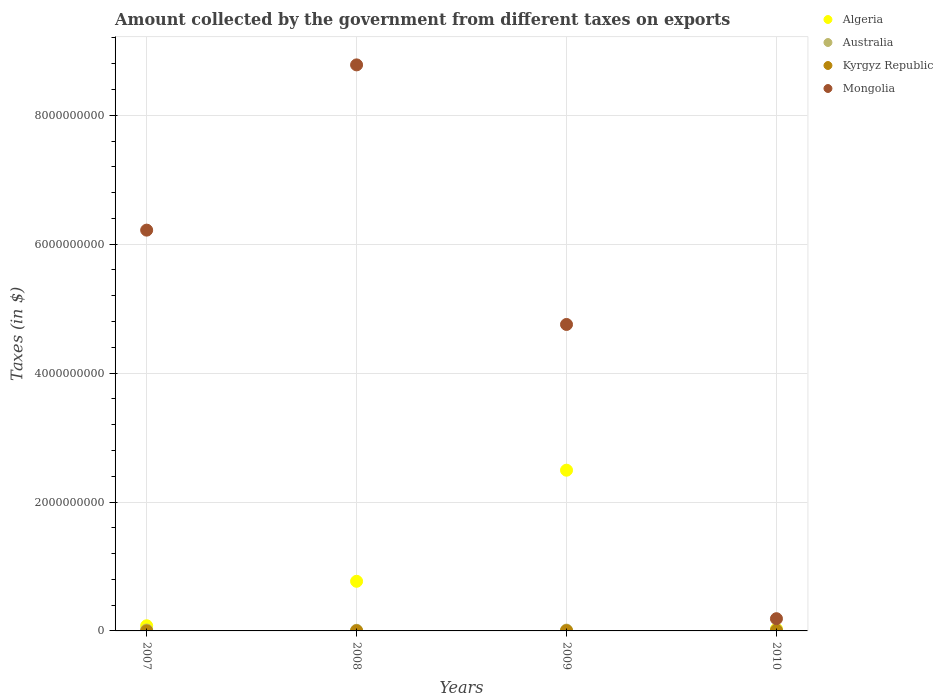What is the amount collected by the government from taxes on exports in Kyrgyz Republic in 2008?
Offer a terse response. 1.81e+06. Across all years, what is the maximum amount collected by the government from taxes on exports in Kyrgyz Republic?
Make the answer very short. 5.91e+06. Across all years, what is the minimum amount collected by the government from taxes on exports in Australia?
Your response must be concise. 1.00e+07. In which year was the amount collected by the government from taxes on exports in Mongolia minimum?
Offer a very short reply. 2010. What is the total amount collected by the government from taxes on exports in Mongolia in the graph?
Keep it short and to the point. 1.99e+1. What is the difference between the amount collected by the government from taxes on exports in Kyrgyz Republic in 2008 and that in 2009?
Make the answer very short. -1.76e+06. What is the difference between the amount collected by the government from taxes on exports in Mongolia in 2008 and the amount collected by the government from taxes on exports in Australia in 2007?
Make the answer very short. 8.77e+09. What is the average amount collected by the government from taxes on exports in Algeria per year?
Make the answer very short. 8.43e+08. In the year 2008, what is the difference between the amount collected by the government from taxes on exports in Kyrgyz Republic and amount collected by the government from taxes on exports in Algeria?
Your answer should be very brief. -7.68e+08. In how many years, is the amount collected by the government from taxes on exports in Australia greater than 800000000 $?
Provide a succinct answer. 0. What is the ratio of the amount collected by the government from taxes on exports in Australia in 2007 to that in 2009?
Your response must be concise. 1.08. What is the difference between the highest and the second highest amount collected by the government from taxes on exports in Algeria?
Give a very brief answer. 1.72e+09. What is the difference between the highest and the lowest amount collected by the government from taxes on exports in Mongolia?
Provide a succinct answer. 8.59e+09. In how many years, is the amount collected by the government from taxes on exports in Australia greater than the average amount collected by the government from taxes on exports in Australia taken over all years?
Make the answer very short. 3. Is it the case that in every year, the sum of the amount collected by the government from taxes on exports in Mongolia and amount collected by the government from taxes on exports in Australia  is greater than the sum of amount collected by the government from taxes on exports in Algeria and amount collected by the government from taxes on exports in Kyrgyz Republic?
Make the answer very short. No. Is the amount collected by the government from taxes on exports in Kyrgyz Republic strictly less than the amount collected by the government from taxes on exports in Mongolia over the years?
Give a very brief answer. Yes. How many dotlines are there?
Keep it short and to the point. 4. How many years are there in the graph?
Give a very brief answer. 4. What is the difference between two consecutive major ticks on the Y-axis?
Your answer should be very brief. 2.00e+09. Where does the legend appear in the graph?
Ensure brevity in your answer.  Top right. How are the legend labels stacked?
Give a very brief answer. Vertical. What is the title of the graph?
Your answer should be compact. Amount collected by the government from different taxes on exports. What is the label or title of the X-axis?
Offer a terse response. Years. What is the label or title of the Y-axis?
Give a very brief answer. Taxes (in $). What is the Taxes (in $) in Algeria in 2007?
Offer a terse response. 8.00e+07. What is the Taxes (in $) in Australia in 2007?
Your response must be concise. 1.40e+07. What is the Taxes (in $) in Kyrgyz Republic in 2007?
Offer a terse response. 1.46e+05. What is the Taxes (in $) of Mongolia in 2007?
Keep it short and to the point. 6.22e+09. What is the Taxes (in $) of Algeria in 2008?
Make the answer very short. 7.70e+08. What is the Taxes (in $) of Kyrgyz Republic in 2008?
Provide a short and direct response. 1.81e+06. What is the Taxes (in $) of Mongolia in 2008?
Your answer should be very brief. 8.78e+09. What is the Taxes (in $) of Algeria in 2009?
Your response must be concise. 2.49e+09. What is the Taxes (in $) in Australia in 2009?
Provide a succinct answer. 1.30e+07. What is the Taxes (in $) in Kyrgyz Republic in 2009?
Ensure brevity in your answer.  3.56e+06. What is the Taxes (in $) in Mongolia in 2009?
Your answer should be very brief. 4.75e+09. What is the Taxes (in $) in Algeria in 2010?
Your answer should be very brief. 3.00e+07. What is the Taxes (in $) of Australia in 2010?
Ensure brevity in your answer.  1.40e+07. What is the Taxes (in $) in Kyrgyz Republic in 2010?
Ensure brevity in your answer.  5.91e+06. What is the Taxes (in $) of Mongolia in 2010?
Give a very brief answer. 1.90e+08. Across all years, what is the maximum Taxes (in $) of Algeria?
Ensure brevity in your answer.  2.49e+09. Across all years, what is the maximum Taxes (in $) in Australia?
Ensure brevity in your answer.  1.40e+07. Across all years, what is the maximum Taxes (in $) in Kyrgyz Republic?
Make the answer very short. 5.91e+06. Across all years, what is the maximum Taxes (in $) in Mongolia?
Offer a terse response. 8.78e+09. Across all years, what is the minimum Taxes (in $) in Algeria?
Provide a succinct answer. 3.00e+07. Across all years, what is the minimum Taxes (in $) in Kyrgyz Republic?
Your answer should be compact. 1.46e+05. Across all years, what is the minimum Taxes (in $) of Mongolia?
Your answer should be very brief. 1.90e+08. What is the total Taxes (in $) of Algeria in the graph?
Your response must be concise. 3.37e+09. What is the total Taxes (in $) of Australia in the graph?
Ensure brevity in your answer.  5.10e+07. What is the total Taxes (in $) of Kyrgyz Republic in the graph?
Your response must be concise. 1.14e+07. What is the total Taxes (in $) in Mongolia in the graph?
Offer a very short reply. 1.99e+1. What is the difference between the Taxes (in $) of Algeria in 2007 and that in 2008?
Your response must be concise. -6.90e+08. What is the difference between the Taxes (in $) in Australia in 2007 and that in 2008?
Provide a short and direct response. 4.00e+06. What is the difference between the Taxes (in $) of Kyrgyz Republic in 2007 and that in 2008?
Make the answer very short. -1.66e+06. What is the difference between the Taxes (in $) of Mongolia in 2007 and that in 2008?
Provide a short and direct response. -2.56e+09. What is the difference between the Taxes (in $) of Algeria in 2007 and that in 2009?
Provide a succinct answer. -2.41e+09. What is the difference between the Taxes (in $) of Australia in 2007 and that in 2009?
Your response must be concise. 1.00e+06. What is the difference between the Taxes (in $) in Kyrgyz Republic in 2007 and that in 2009?
Provide a succinct answer. -3.42e+06. What is the difference between the Taxes (in $) in Mongolia in 2007 and that in 2009?
Your answer should be very brief. 1.46e+09. What is the difference between the Taxes (in $) in Algeria in 2007 and that in 2010?
Provide a short and direct response. 5.00e+07. What is the difference between the Taxes (in $) of Kyrgyz Republic in 2007 and that in 2010?
Make the answer very short. -5.77e+06. What is the difference between the Taxes (in $) in Mongolia in 2007 and that in 2010?
Provide a short and direct response. 6.03e+09. What is the difference between the Taxes (in $) in Algeria in 2008 and that in 2009?
Keep it short and to the point. -1.72e+09. What is the difference between the Taxes (in $) of Kyrgyz Republic in 2008 and that in 2009?
Make the answer very short. -1.76e+06. What is the difference between the Taxes (in $) in Mongolia in 2008 and that in 2009?
Keep it short and to the point. 4.03e+09. What is the difference between the Taxes (in $) of Algeria in 2008 and that in 2010?
Offer a very short reply. 7.40e+08. What is the difference between the Taxes (in $) in Australia in 2008 and that in 2010?
Keep it short and to the point. -4.00e+06. What is the difference between the Taxes (in $) of Kyrgyz Republic in 2008 and that in 2010?
Offer a very short reply. -4.11e+06. What is the difference between the Taxes (in $) in Mongolia in 2008 and that in 2010?
Your answer should be compact. 8.59e+09. What is the difference between the Taxes (in $) of Algeria in 2009 and that in 2010?
Keep it short and to the point. 2.46e+09. What is the difference between the Taxes (in $) of Australia in 2009 and that in 2010?
Keep it short and to the point. -1.00e+06. What is the difference between the Taxes (in $) in Kyrgyz Republic in 2009 and that in 2010?
Ensure brevity in your answer.  -2.35e+06. What is the difference between the Taxes (in $) in Mongolia in 2009 and that in 2010?
Provide a short and direct response. 4.57e+09. What is the difference between the Taxes (in $) of Algeria in 2007 and the Taxes (in $) of Australia in 2008?
Provide a short and direct response. 7.00e+07. What is the difference between the Taxes (in $) of Algeria in 2007 and the Taxes (in $) of Kyrgyz Republic in 2008?
Provide a short and direct response. 7.82e+07. What is the difference between the Taxes (in $) of Algeria in 2007 and the Taxes (in $) of Mongolia in 2008?
Provide a succinct answer. -8.70e+09. What is the difference between the Taxes (in $) of Australia in 2007 and the Taxes (in $) of Kyrgyz Republic in 2008?
Make the answer very short. 1.22e+07. What is the difference between the Taxes (in $) of Australia in 2007 and the Taxes (in $) of Mongolia in 2008?
Keep it short and to the point. -8.77e+09. What is the difference between the Taxes (in $) of Kyrgyz Republic in 2007 and the Taxes (in $) of Mongolia in 2008?
Give a very brief answer. -8.78e+09. What is the difference between the Taxes (in $) in Algeria in 2007 and the Taxes (in $) in Australia in 2009?
Provide a short and direct response. 6.70e+07. What is the difference between the Taxes (in $) in Algeria in 2007 and the Taxes (in $) in Kyrgyz Republic in 2009?
Give a very brief answer. 7.64e+07. What is the difference between the Taxes (in $) in Algeria in 2007 and the Taxes (in $) in Mongolia in 2009?
Your answer should be compact. -4.67e+09. What is the difference between the Taxes (in $) in Australia in 2007 and the Taxes (in $) in Kyrgyz Republic in 2009?
Ensure brevity in your answer.  1.04e+07. What is the difference between the Taxes (in $) in Australia in 2007 and the Taxes (in $) in Mongolia in 2009?
Keep it short and to the point. -4.74e+09. What is the difference between the Taxes (in $) in Kyrgyz Republic in 2007 and the Taxes (in $) in Mongolia in 2009?
Ensure brevity in your answer.  -4.75e+09. What is the difference between the Taxes (in $) in Algeria in 2007 and the Taxes (in $) in Australia in 2010?
Make the answer very short. 6.60e+07. What is the difference between the Taxes (in $) in Algeria in 2007 and the Taxes (in $) in Kyrgyz Republic in 2010?
Provide a succinct answer. 7.41e+07. What is the difference between the Taxes (in $) of Algeria in 2007 and the Taxes (in $) of Mongolia in 2010?
Make the answer very short. -1.10e+08. What is the difference between the Taxes (in $) of Australia in 2007 and the Taxes (in $) of Kyrgyz Republic in 2010?
Your response must be concise. 8.09e+06. What is the difference between the Taxes (in $) in Australia in 2007 and the Taxes (in $) in Mongolia in 2010?
Your answer should be very brief. -1.76e+08. What is the difference between the Taxes (in $) of Kyrgyz Republic in 2007 and the Taxes (in $) of Mongolia in 2010?
Keep it short and to the point. -1.90e+08. What is the difference between the Taxes (in $) in Algeria in 2008 and the Taxes (in $) in Australia in 2009?
Your response must be concise. 7.57e+08. What is the difference between the Taxes (in $) in Algeria in 2008 and the Taxes (in $) in Kyrgyz Republic in 2009?
Offer a terse response. 7.66e+08. What is the difference between the Taxes (in $) in Algeria in 2008 and the Taxes (in $) in Mongolia in 2009?
Keep it short and to the point. -3.98e+09. What is the difference between the Taxes (in $) in Australia in 2008 and the Taxes (in $) in Kyrgyz Republic in 2009?
Give a very brief answer. 6.44e+06. What is the difference between the Taxes (in $) in Australia in 2008 and the Taxes (in $) in Mongolia in 2009?
Make the answer very short. -4.74e+09. What is the difference between the Taxes (in $) of Kyrgyz Republic in 2008 and the Taxes (in $) of Mongolia in 2009?
Make the answer very short. -4.75e+09. What is the difference between the Taxes (in $) in Algeria in 2008 and the Taxes (in $) in Australia in 2010?
Your answer should be very brief. 7.56e+08. What is the difference between the Taxes (in $) in Algeria in 2008 and the Taxes (in $) in Kyrgyz Republic in 2010?
Offer a terse response. 7.64e+08. What is the difference between the Taxes (in $) of Algeria in 2008 and the Taxes (in $) of Mongolia in 2010?
Keep it short and to the point. 5.80e+08. What is the difference between the Taxes (in $) in Australia in 2008 and the Taxes (in $) in Kyrgyz Republic in 2010?
Keep it short and to the point. 4.09e+06. What is the difference between the Taxes (in $) in Australia in 2008 and the Taxes (in $) in Mongolia in 2010?
Your answer should be compact. -1.80e+08. What is the difference between the Taxes (in $) of Kyrgyz Republic in 2008 and the Taxes (in $) of Mongolia in 2010?
Ensure brevity in your answer.  -1.88e+08. What is the difference between the Taxes (in $) of Algeria in 2009 and the Taxes (in $) of Australia in 2010?
Make the answer very short. 2.48e+09. What is the difference between the Taxes (in $) in Algeria in 2009 and the Taxes (in $) in Kyrgyz Republic in 2010?
Ensure brevity in your answer.  2.49e+09. What is the difference between the Taxes (in $) of Algeria in 2009 and the Taxes (in $) of Mongolia in 2010?
Give a very brief answer. 2.30e+09. What is the difference between the Taxes (in $) of Australia in 2009 and the Taxes (in $) of Kyrgyz Republic in 2010?
Your response must be concise. 7.09e+06. What is the difference between the Taxes (in $) of Australia in 2009 and the Taxes (in $) of Mongolia in 2010?
Provide a short and direct response. -1.77e+08. What is the difference between the Taxes (in $) in Kyrgyz Republic in 2009 and the Taxes (in $) in Mongolia in 2010?
Offer a very short reply. -1.86e+08. What is the average Taxes (in $) of Algeria per year?
Give a very brief answer. 8.43e+08. What is the average Taxes (in $) of Australia per year?
Give a very brief answer. 1.28e+07. What is the average Taxes (in $) of Kyrgyz Republic per year?
Provide a short and direct response. 2.86e+06. What is the average Taxes (in $) of Mongolia per year?
Keep it short and to the point. 4.99e+09. In the year 2007, what is the difference between the Taxes (in $) in Algeria and Taxes (in $) in Australia?
Provide a short and direct response. 6.60e+07. In the year 2007, what is the difference between the Taxes (in $) in Algeria and Taxes (in $) in Kyrgyz Republic?
Ensure brevity in your answer.  7.99e+07. In the year 2007, what is the difference between the Taxes (in $) in Algeria and Taxes (in $) in Mongolia?
Offer a terse response. -6.14e+09. In the year 2007, what is the difference between the Taxes (in $) of Australia and Taxes (in $) of Kyrgyz Republic?
Give a very brief answer. 1.39e+07. In the year 2007, what is the difference between the Taxes (in $) of Australia and Taxes (in $) of Mongolia?
Give a very brief answer. -6.20e+09. In the year 2007, what is the difference between the Taxes (in $) in Kyrgyz Republic and Taxes (in $) in Mongolia?
Give a very brief answer. -6.22e+09. In the year 2008, what is the difference between the Taxes (in $) of Algeria and Taxes (in $) of Australia?
Keep it short and to the point. 7.60e+08. In the year 2008, what is the difference between the Taxes (in $) in Algeria and Taxes (in $) in Kyrgyz Republic?
Your answer should be very brief. 7.68e+08. In the year 2008, what is the difference between the Taxes (in $) in Algeria and Taxes (in $) in Mongolia?
Make the answer very short. -8.01e+09. In the year 2008, what is the difference between the Taxes (in $) of Australia and Taxes (in $) of Kyrgyz Republic?
Provide a succinct answer. 8.19e+06. In the year 2008, what is the difference between the Taxes (in $) in Australia and Taxes (in $) in Mongolia?
Offer a very short reply. -8.77e+09. In the year 2008, what is the difference between the Taxes (in $) of Kyrgyz Republic and Taxes (in $) of Mongolia?
Offer a very short reply. -8.78e+09. In the year 2009, what is the difference between the Taxes (in $) in Algeria and Taxes (in $) in Australia?
Your answer should be very brief. 2.48e+09. In the year 2009, what is the difference between the Taxes (in $) in Algeria and Taxes (in $) in Kyrgyz Republic?
Provide a short and direct response. 2.49e+09. In the year 2009, what is the difference between the Taxes (in $) of Algeria and Taxes (in $) of Mongolia?
Keep it short and to the point. -2.26e+09. In the year 2009, what is the difference between the Taxes (in $) in Australia and Taxes (in $) in Kyrgyz Republic?
Offer a very short reply. 9.44e+06. In the year 2009, what is the difference between the Taxes (in $) in Australia and Taxes (in $) in Mongolia?
Give a very brief answer. -4.74e+09. In the year 2009, what is the difference between the Taxes (in $) of Kyrgyz Republic and Taxes (in $) of Mongolia?
Keep it short and to the point. -4.75e+09. In the year 2010, what is the difference between the Taxes (in $) of Algeria and Taxes (in $) of Australia?
Your answer should be very brief. 1.60e+07. In the year 2010, what is the difference between the Taxes (in $) in Algeria and Taxes (in $) in Kyrgyz Republic?
Ensure brevity in your answer.  2.41e+07. In the year 2010, what is the difference between the Taxes (in $) in Algeria and Taxes (in $) in Mongolia?
Give a very brief answer. -1.60e+08. In the year 2010, what is the difference between the Taxes (in $) of Australia and Taxes (in $) of Kyrgyz Republic?
Ensure brevity in your answer.  8.09e+06. In the year 2010, what is the difference between the Taxes (in $) in Australia and Taxes (in $) in Mongolia?
Ensure brevity in your answer.  -1.76e+08. In the year 2010, what is the difference between the Taxes (in $) in Kyrgyz Republic and Taxes (in $) in Mongolia?
Give a very brief answer. -1.84e+08. What is the ratio of the Taxes (in $) in Algeria in 2007 to that in 2008?
Ensure brevity in your answer.  0.1. What is the ratio of the Taxes (in $) in Kyrgyz Republic in 2007 to that in 2008?
Your answer should be very brief. 0.08. What is the ratio of the Taxes (in $) in Mongolia in 2007 to that in 2008?
Offer a terse response. 0.71. What is the ratio of the Taxes (in $) of Algeria in 2007 to that in 2009?
Provide a short and direct response. 0.03. What is the ratio of the Taxes (in $) of Australia in 2007 to that in 2009?
Ensure brevity in your answer.  1.08. What is the ratio of the Taxes (in $) in Kyrgyz Republic in 2007 to that in 2009?
Offer a terse response. 0.04. What is the ratio of the Taxes (in $) of Mongolia in 2007 to that in 2009?
Keep it short and to the point. 1.31. What is the ratio of the Taxes (in $) of Algeria in 2007 to that in 2010?
Keep it short and to the point. 2.67. What is the ratio of the Taxes (in $) of Australia in 2007 to that in 2010?
Keep it short and to the point. 1. What is the ratio of the Taxes (in $) in Kyrgyz Republic in 2007 to that in 2010?
Keep it short and to the point. 0.02. What is the ratio of the Taxes (in $) of Mongolia in 2007 to that in 2010?
Provide a short and direct response. 32.76. What is the ratio of the Taxes (in $) of Algeria in 2008 to that in 2009?
Keep it short and to the point. 0.31. What is the ratio of the Taxes (in $) of Australia in 2008 to that in 2009?
Make the answer very short. 0.77. What is the ratio of the Taxes (in $) in Kyrgyz Republic in 2008 to that in 2009?
Give a very brief answer. 0.51. What is the ratio of the Taxes (in $) in Mongolia in 2008 to that in 2009?
Your answer should be compact. 1.85. What is the ratio of the Taxes (in $) in Algeria in 2008 to that in 2010?
Offer a very short reply. 25.67. What is the ratio of the Taxes (in $) of Kyrgyz Republic in 2008 to that in 2010?
Provide a short and direct response. 0.31. What is the ratio of the Taxes (in $) of Mongolia in 2008 to that in 2010?
Give a very brief answer. 46.27. What is the ratio of the Taxes (in $) in Algeria in 2009 to that in 2010?
Your response must be concise. 83.12. What is the ratio of the Taxes (in $) of Kyrgyz Republic in 2009 to that in 2010?
Your answer should be compact. 0.6. What is the ratio of the Taxes (in $) of Mongolia in 2009 to that in 2010?
Provide a succinct answer. 25.05. What is the difference between the highest and the second highest Taxes (in $) of Algeria?
Make the answer very short. 1.72e+09. What is the difference between the highest and the second highest Taxes (in $) in Australia?
Your answer should be very brief. 0. What is the difference between the highest and the second highest Taxes (in $) in Kyrgyz Republic?
Give a very brief answer. 2.35e+06. What is the difference between the highest and the second highest Taxes (in $) of Mongolia?
Keep it short and to the point. 2.56e+09. What is the difference between the highest and the lowest Taxes (in $) of Algeria?
Keep it short and to the point. 2.46e+09. What is the difference between the highest and the lowest Taxes (in $) in Australia?
Make the answer very short. 4.00e+06. What is the difference between the highest and the lowest Taxes (in $) in Kyrgyz Republic?
Offer a terse response. 5.77e+06. What is the difference between the highest and the lowest Taxes (in $) in Mongolia?
Your answer should be compact. 8.59e+09. 